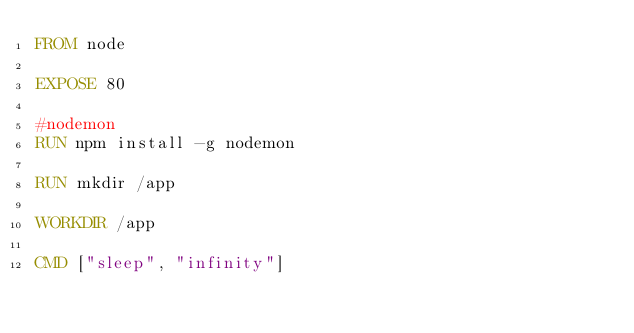Convert code to text. <code><loc_0><loc_0><loc_500><loc_500><_Dockerfile_>FROM node

EXPOSE 80

#nodemon
RUN npm install -g nodemon

RUN mkdir /app

WORKDIR /app

CMD ["sleep", "infinity"]</code> 